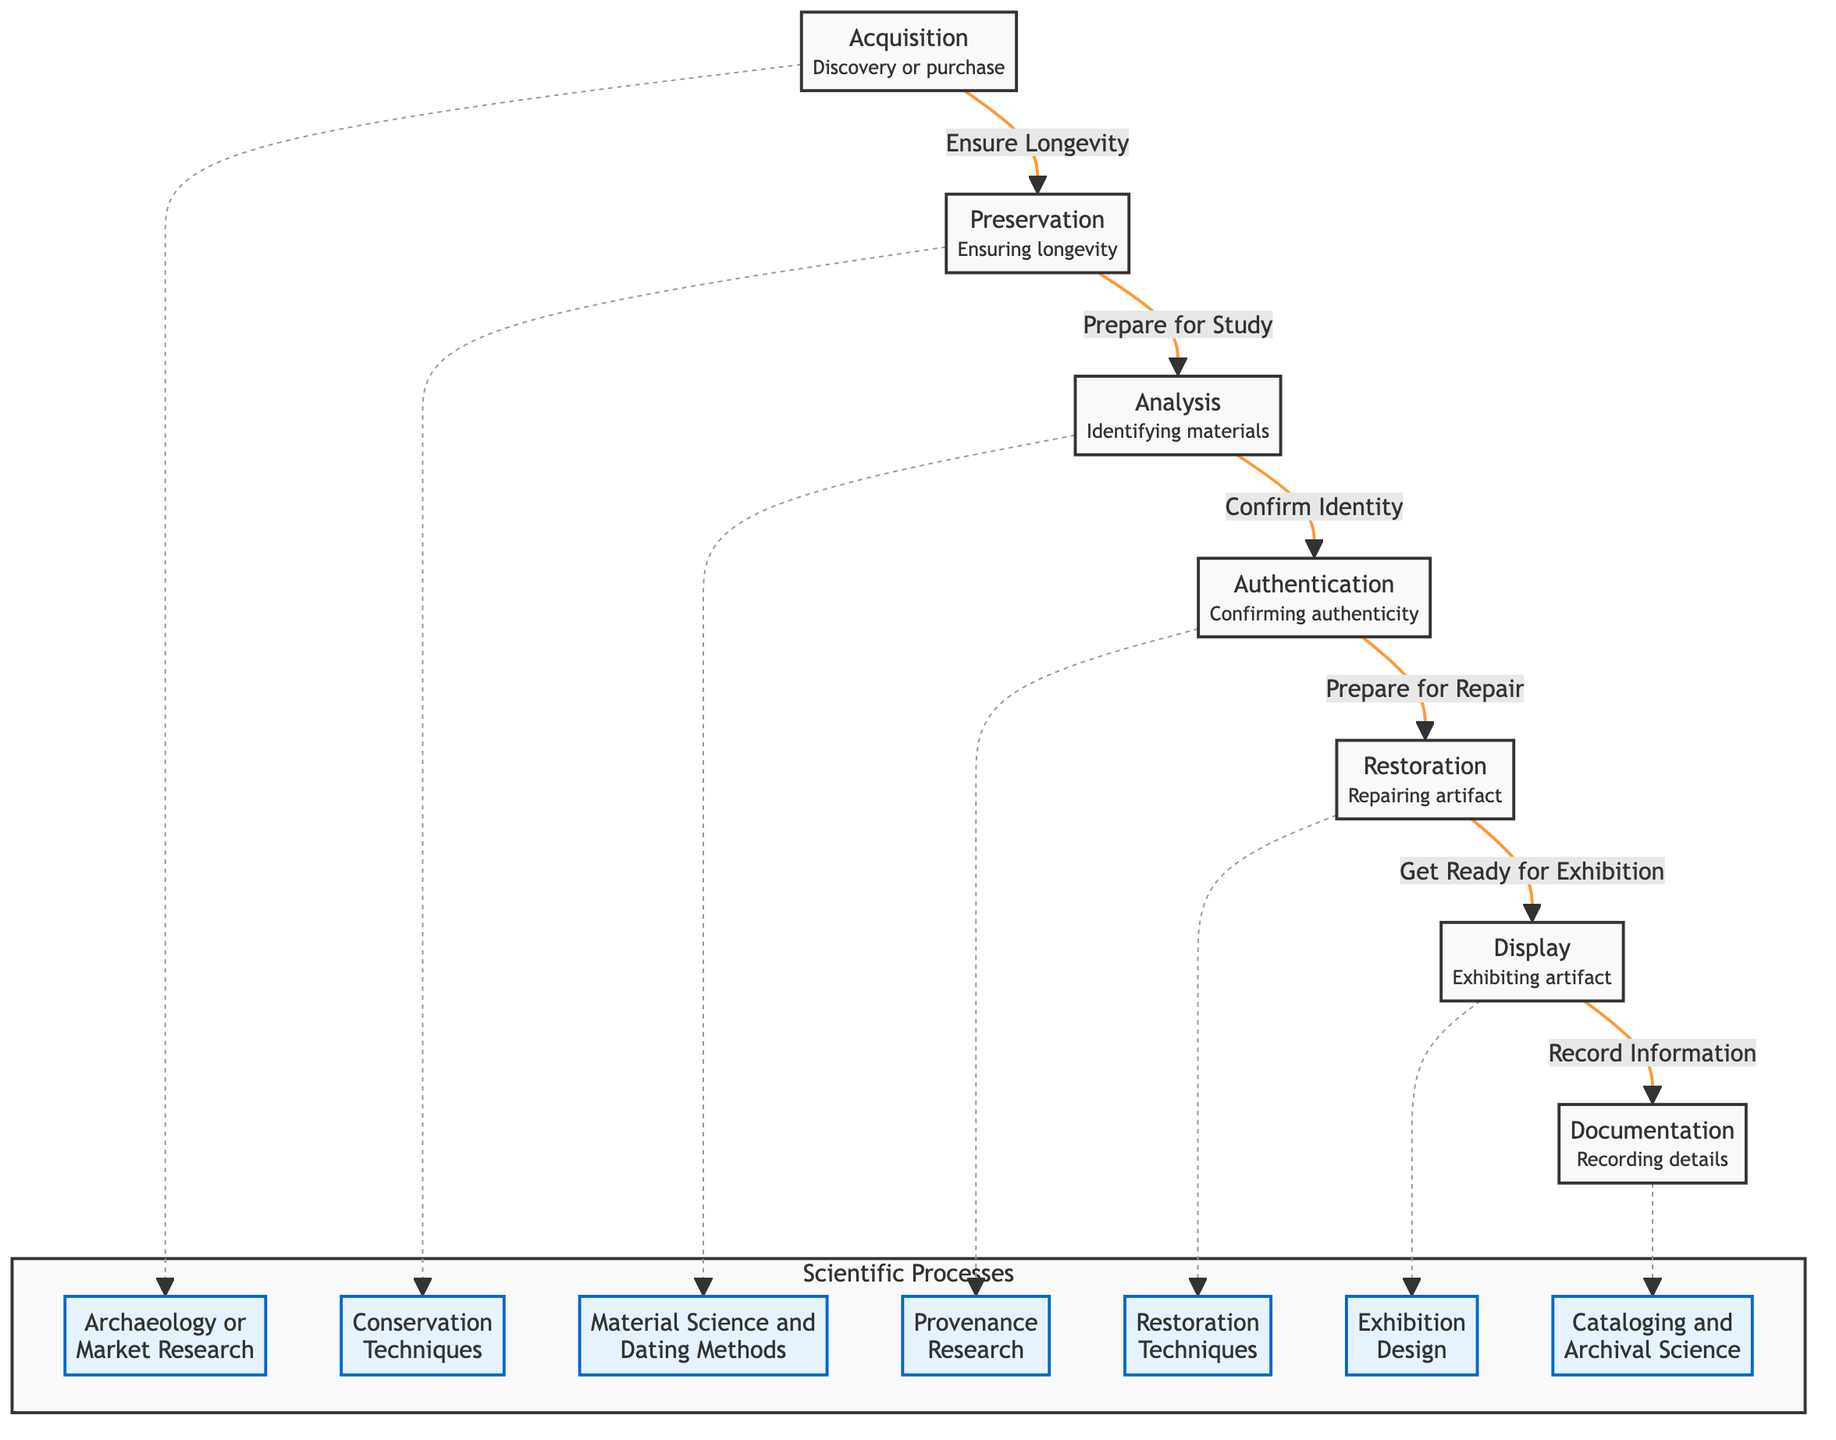What is the first step in the life cycle of a vintage artifact? The diagram indicates that the first step is "Acquisition," which involves discovery or purchase of the artifact.
Answer: Acquisition How many main processes are depicted in the diagram? By counting the nodes in the flowchart, we find there are seven main processes listed (A to G).
Answer: 7 What follows after "Preservation"? According to the flowchart, "Analysis" is the next step that follows "Preservation."
Answer: Analysis Which scientific process is associated with the "Restoration" step? The diagram links "Restoration" to the scientific process of "Restoration Techniques." This connection is indicated with a dashed line.
Answer: Restoration Techniques What is the relationship between "Display" and "Documentation"? The flow shows that "Display" leads to "Documentation," indicating that recording details comes after exhibiting the artifact.
Answer: Display leads to Documentation Which step confirms the artifact's identity? The "Authentication" step is the one responsible for confirming the artifact's identity, as indicated in the diagram.
Answer: Authentication How does "Acquisition" connect to scientific processes? The flowchart shows a dashed line from "Acquisition" to "Archaeology or Market Research," indicating that this scientific process is relevant to the acquisition of vintage artifacts.
Answer: Archaeology or Market Research What does the "Authentication" step prepare for? The "Authentication" step prepares for the "Restoration" step according to the connections in the diagram, as it leads directly to that node.
Answer: Restoration What are the last two steps in the life cycle depicted? The diagram indicates that the last two steps are "Display" and "Documentation," showing the sequence towards the end of the life cycle.
Answer: Display, Documentation 